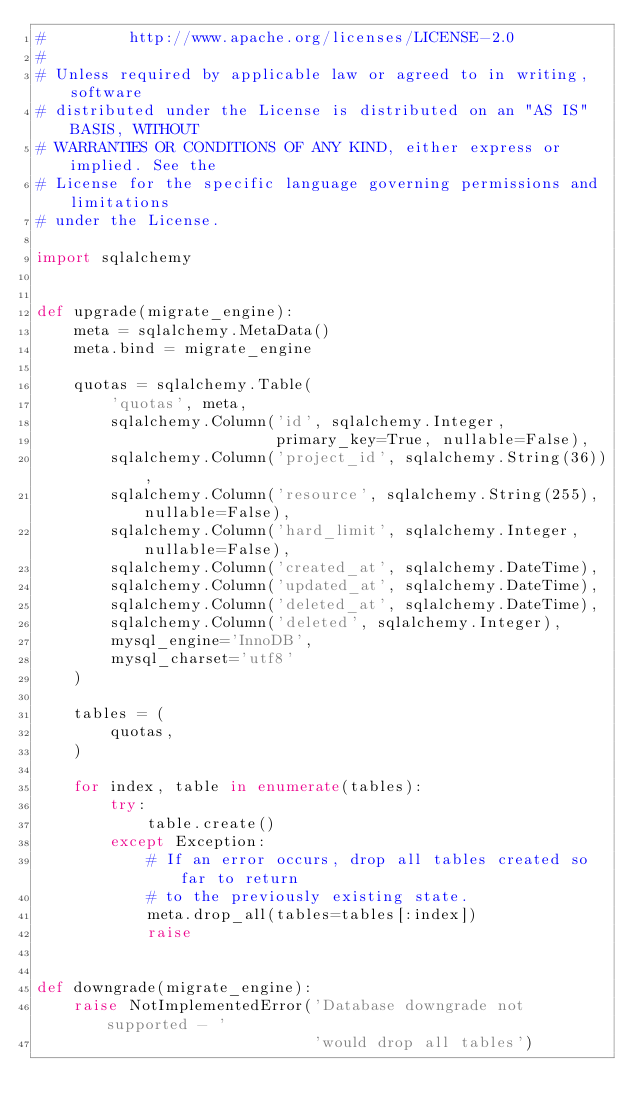Convert code to text. <code><loc_0><loc_0><loc_500><loc_500><_Python_>#         http://www.apache.org/licenses/LICENSE-2.0
#
# Unless required by applicable law or agreed to in writing, software
# distributed under the License is distributed on an "AS IS" BASIS, WITHOUT
# WARRANTIES OR CONDITIONS OF ANY KIND, either express or implied. See the
# License for the specific language governing permissions and limitations
# under the License.

import sqlalchemy


def upgrade(migrate_engine):
    meta = sqlalchemy.MetaData()
    meta.bind = migrate_engine

    quotas = sqlalchemy.Table(
        'quotas', meta,
        sqlalchemy.Column('id', sqlalchemy.Integer,
                          primary_key=True, nullable=False),
        sqlalchemy.Column('project_id', sqlalchemy.String(36)),
        sqlalchemy.Column('resource', sqlalchemy.String(255), nullable=False),
        sqlalchemy.Column('hard_limit', sqlalchemy.Integer, nullable=False),
        sqlalchemy.Column('created_at', sqlalchemy.DateTime),
        sqlalchemy.Column('updated_at', sqlalchemy.DateTime),
        sqlalchemy.Column('deleted_at', sqlalchemy.DateTime),
        sqlalchemy.Column('deleted', sqlalchemy.Integer),
        mysql_engine='InnoDB',
        mysql_charset='utf8'
    )

    tables = (
        quotas,
    )

    for index, table in enumerate(tables):
        try:
            table.create()
        except Exception:
            # If an error occurs, drop all tables created so far to return
            # to the previously existing state.
            meta.drop_all(tables=tables[:index])
            raise


def downgrade(migrate_engine):
    raise NotImplementedError('Database downgrade not supported - '
                              'would drop all tables')
</code> 